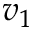<formula> <loc_0><loc_0><loc_500><loc_500>v _ { 1 }</formula> 